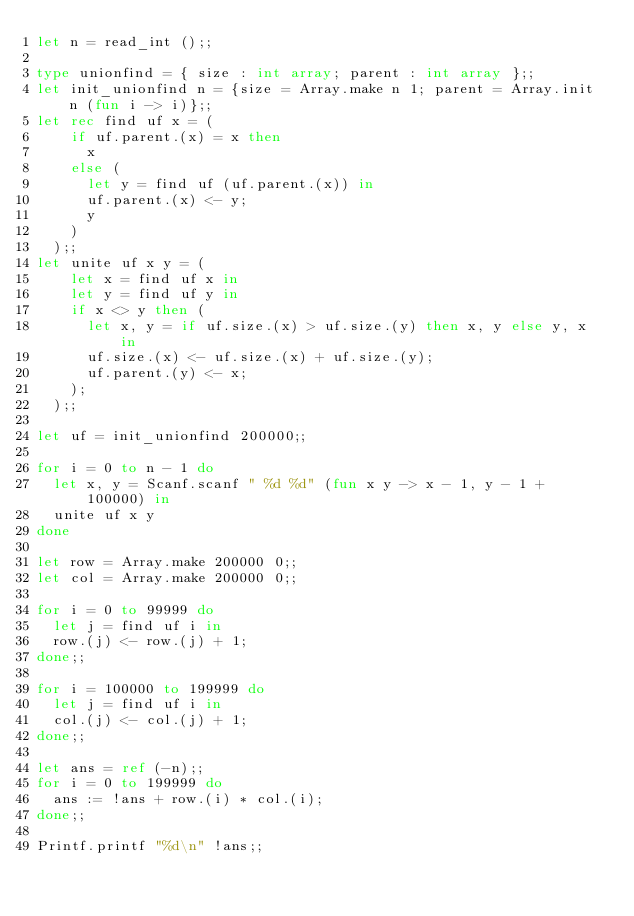Convert code to text. <code><loc_0><loc_0><loc_500><loc_500><_OCaml_>let n = read_int ();;

type unionfind = { size : int array; parent : int array };;
let init_unionfind n = {size = Array.make n 1; parent = Array.init n (fun i -> i)};;
let rec find uf x = (
    if uf.parent.(x) = x then
      x
    else (
      let y = find uf (uf.parent.(x)) in
      uf.parent.(x) <- y;
      y
    )
  );;
let unite uf x y = (
    let x = find uf x in
    let y = find uf y in
    if x <> y then (
      let x, y = if uf.size.(x) > uf.size.(y) then x, y else y, x in
      uf.size.(x) <- uf.size.(x) + uf.size.(y);
      uf.parent.(y) <- x;
    );
  );;

let uf = init_unionfind 200000;;

for i = 0 to n - 1 do
  let x, y = Scanf.scanf " %d %d" (fun x y -> x - 1, y - 1 + 100000) in
  unite uf x y
done

let row = Array.make 200000 0;;
let col = Array.make 200000 0;;

for i = 0 to 99999 do
  let j = find uf i in
  row.(j) <- row.(j) + 1;
done;;

for i = 100000 to 199999 do
  let j = find uf i in
  col.(j) <- col.(j) + 1;
done;;

let ans = ref (-n);;
for i = 0 to 199999 do
  ans := !ans + row.(i) * col.(i);
done;;

Printf.printf "%d\n" !ans;;
</code> 